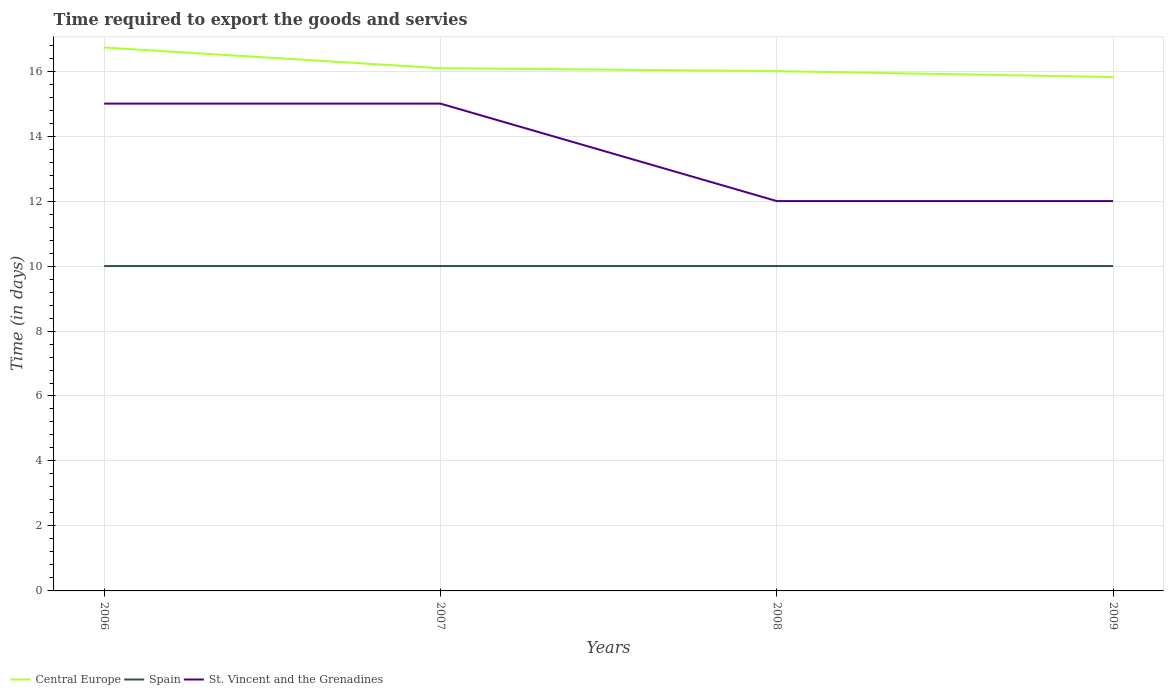How many different coloured lines are there?
Keep it short and to the point. 3. Is the number of lines equal to the number of legend labels?
Offer a terse response. Yes. Across all years, what is the maximum number of days required to export the goods and services in St. Vincent and the Grenadines?
Keep it short and to the point. 12. In which year was the number of days required to export the goods and services in Central Europe maximum?
Your response must be concise. 2009. What is the total number of days required to export the goods and services in St. Vincent and the Grenadines in the graph?
Offer a very short reply. 0. What is the difference between the highest and the second highest number of days required to export the goods and services in Central Europe?
Offer a terse response. 0.91. How many lines are there?
Give a very brief answer. 3. How many years are there in the graph?
Your response must be concise. 4. What is the difference between two consecutive major ticks on the Y-axis?
Your answer should be very brief. 2. Does the graph contain grids?
Provide a succinct answer. Yes. How are the legend labels stacked?
Keep it short and to the point. Horizontal. What is the title of the graph?
Make the answer very short. Time required to export the goods and servies. Does "Seychelles" appear as one of the legend labels in the graph?
Keep it short and to the point. No. What is the label or title of the Y-axis?
Your answer should be compact. Time (in days). What is the Time (in days) in Central Europe in 2006?
Give a very brief answer. 16.73. What is the Time (in days) of Central Europe in 2007?
Your answer should be very brief. 16.09. What is the Time (in days) in Spain in 2008?
Your answer should be very brief. 10. What is the Time (in days) in Central Europe in 2009?
Your answer should be very brief. 15.82. Across all years, what is the maximum Time (in days) of Central Europe?
Your answer should be very brief. 16.73. Across all years, what is the maximum Time (in days) of Spain?
Provide a short and direct response. 10. Across all years, what is the minimum Time (in days) of Central Europe?
Your answer should be very brief. 15.82. What is the total Time (in days) of Central Europe in the graph?
Your response must be concise. 64.64. What is the total Time (in days) in Spain in the graph?
Give a very brief answer. 40. What is the total Time (in days) in St. Vincent and the Grenadines in the graph?
Offer a very short reply. 54. What is the difference between the Time (in days) of Central Europe in 2006 and that in 2007?
Keep it short and to the point. 0.64. What is the difference between the Time (in days) of Central Europe in 2006 and that in 2008?
Offer a terse response. 0.73. What is the difference between the Time (in days) in Spain in 2006 and that in 2008?
Offer a very short reply. 0. What is the difference between the Time (in days) in St. Vincent and the Grenadines in 2006 and that in 2008?
Offer a very short reply. 3. What is the difference between the Time (in days) of St. Vincent and the Grenadines in 2006 and that in 2009?
Provide a short and direct response. 3. What is the difference between the Time (in days) in Central Europe in 2007 and that in 2008?
Offer a very short reply. 0.09. What is the difference between the Time (in days) in St. Vincent and the Grenadines in 2007 and that in 2008?
Your answer should be very brief. 3. What is the difference between the Time (in days) in Central Europe in 2007 and that in 2009?
Your answer should be very brief. 0.27. What is the difference between the Time (in days) of Spain in 2007 and that in 2009?
Provide a succinct answer. 0. What is the difference between the Time (in days) in Central Europe in 2008 and that in 2009?
Provide a short and direct response. 0.18. What is the difference between the Time (in days) in Spain in 2008 and that in 2009?
Offer a terse response. 0. What is the difference between the Time (in days) in St. Vincent and the Grenadines in 2008 and that in 2009?
Offer a terse response. 0. What is the difference between the Time (in days) in Central Europe in 2006 and the Time (in days) in Spain in 2007?
Offer a terse response. 6.73. What is the difference between the Time (in days) in Central Europe in 2006 and the Time (in days) in St. Vincent and the Grenadines in 2007?
Keep it short and to the point. 1.73. What is the difference between the Time (in days) of Spain in 2006 and the Time (in days) of St. Vincent and the Grenadines in 2007?
Keep it short and to the point. -5. What is the difference between the Time (in days) in Central Europe in 2006 and the Time (in days) in Spain in 2008?
Provide a succinct answer. 6.73. What is the difference between the Time (in days) in Central Europe in 2006 and the Time (in days) in St. Vincent and the Grenadines in 2008?
Offer a terse response. 4.73. What is the difference between the Time (in days) in Central Europe in 2006 and the Time (in days) in Spain in 2009?
Your answer should be very brief. 6.73. What is the difference between the Time (in days) in Central Europe in 2006 and the Time (in days) in St. Vincent and the Grenadines in 2009?
Provide a succinct answer. 4.73. What is the difference between the Time (in days) of Central Europe in 2007 and the Time (in days) of Spain in 2008?
Your answer should be compact. 6.09. What is the difference between the Time (in days) in Central Europe in 2007 and the Time (in days) in St. Vincent and the Grenadines in 2008?
Provide a succinct answer. 4.09. What is the difference between the Time (in days) of Spain in 2007 and the Time (in days) of St. Vincent and the Grenadines in 2008?
Provide a succinct answer. -2. What is the difference between the Time (in days) of Central Europe in 2007 and the Time (in days) of Spain in 2009?
Offer a terse response. 6.09. What is the difference between the Time (in days) in Central Europe in 2007 and the Time (in days) in St. Vincent and the Grenadines in 2009?
Keep it short and to the point. 4.09. What is the difference between the Time (in days) of Central Europe in 2008 and the Time (in days) of St. Vincent and the Grenadines in 2009?
Ensure brevity in your answer.  4. What is the difference between the Time (in days) of Spain in 2008 and the Time (in days) of St. Vincent and the Grenadines in 2009?
Your response must be concise. -2. What is the average Time (in days) in Central Europe per year?
Offer a very short reply. 16.16. What is the average Time (in days) in St. Vincent and the Grenadines per year?
Offer a terse response. 13.5. In the year 2006, what is the difference between the Time (in days) of Central Europe and Time (in days) of Spain?
Your response must be concise. 6.73. In the year 2006, what is the difference between the Time (in days) of Central Europe and Time (in days) of St. Vincent and the Grenadines?
Make the answer very short. 1.73. In the year 2007, what is the difference between the Time (in days) in Central Europe and Time (in days) in Spain?
Offer a very short reply. 6.09. In the year 2007, what is the difference between the Time (in days) in Spain and Time (in days) in St. Vincent and the Grenadines?
Offer a very short reply. -5. In the year 2008, what is the difference between the Time (in days) in Central Europe and Time (in days) in St. Vincent and the Grenadines?
Provide a short and direct response. 4. In the year 2009, what is the difference between the Time (in days) of Central Europe and Time (in days) of Spain?
Provide a succinct answer. 5.82. In the year 2009, what is the difference between the Time (in days) of Central Europe and Time (in days) of St. Vincent and the Grenadines?
Offer a terse response. 3.82. In the year 2009, what is the difference between the Time (in days) of Spain and Time (in days) of St. Vincent and the Grenadines?
Provide a succinct answer. -2. What is the ratio of the Time (in days) in Central Europe in 2006 to that in 2007?
Offer a very short reply. 1.04. What is the ratio of the Time (in days) of Spain in 2006 to that in 2007?
Offer a terse response. 1. What is the ratio of the Time (in days) in St. Vincent and the Grenadines in 2006 to that in 2007?
Offer a terse response. 1. What is the ratio of the Time (in days) in Central Europe in 2006 to that in 2008?
Your answer should be very brief. 1.05. What is the ratio of the Time (in days) in Spain in 2006 to that in 2008?
Ensure brevity in your answer.  1. What is the ratio of the Time (in days) of Central Europe in 2006 to that in 2009?
Provide a succinct answer. 1.06. What is the ratio of the Time (in days) of Central Europe in 2007 to that in 2008?
Ensure brevity in your answer.  1.01. What is the ratio of the Time (in days) in Central Europe in 2007 to that in 2009?
Give a very brief answer. 1.02. What is the ratio of the Time (in days) in Spain in 2007 to that in 2009?
Give a very brief answer. 1. What is the ratio of the Time (in days) in St. Vincent and the Grenadines in 2007 to that in 2009?
Make the answer very short. 1.25. What is the ratio of the Time (in days) of Central Europe in 2008 to that in 2009?
Offer a terse response. 1.01. What is the ratio of the Time (in days) in Spain in 2008 to that in 2009?
Your response must be concise. 1. What is the difference between the highest and the second highest Time (in days) in Central Europe?
Provide a succinct answer. 0.64. What is the difference between the highest and the second highest Time (in days) in Spain?
Give a very brief answer. 0. What is the difference between the highest and the second highest Time (in days) in St. Vincent and the Grenadines?
Give a very brief answer. 0. What is the difference between the highest and the lowest Time (in days) of Spain?
Your answer should be very brief. 0. What is the difference between the highest and the lowest Time (in days) in St. Vincent and the Grenadines?
Your answer should be compact. 3. 